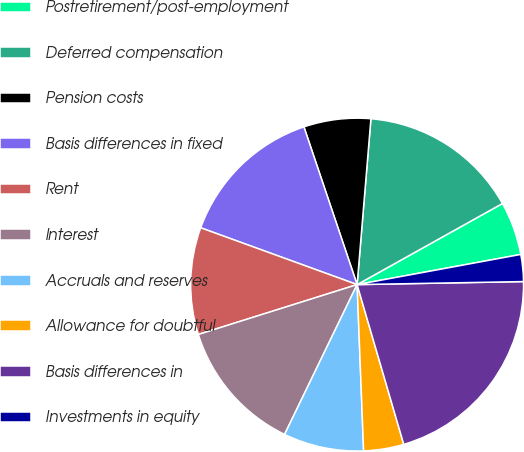Convert chart. <chart><loc_0><loc_0><loc_500><loc_500><pie_chart><fcel>Postretirement/post-employment<fcel>Deferred compensation<fcel>Pension costs<fcel>Basis differences in fixed<fcel>Rent<fcel>Interest<fcel>Accruals and reserves<fcel>Allowance for doubtful<fcel>Basis differences in<fcel>Investments in equity<nl><fcel>5.2%<fcel>15.58%<fcel>6.5%<fcel>14.28%<fcel>10.39%<fcel>12.98%<fcel>7.8%<fcel>3.9%<fcel>20.77%<fcel>2.61%<nl></chart> 